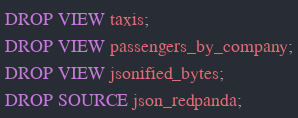Convert code to text. <code><loc_0><loc_0><loc_500><loc_500><_SQL_>DROP VIEW taxis;
DROP VIEW passengers_by_company;
DROP VIEW jsonified_bytes;
DROP SOURCE json_redpanda;</code> 